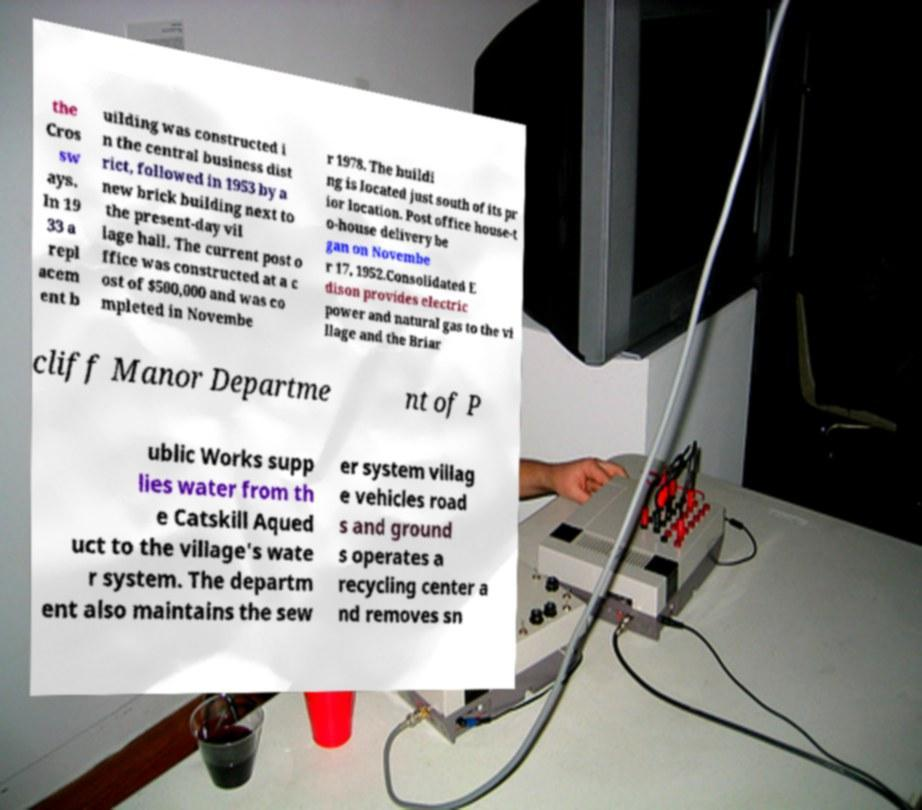For documentation purposes, I need the text within this image transcribed. Could you provide that? the Cros sw ays. In 19 33 a repl acem ent b uilding was constructed i n the central business dist rict, followed in 1953 by a new brick building next to the present-day vil lage hall. The current post o ffice was constructed at a c ost of $500,000 and was co mpleted in Novembe r 1978. The buildi ng is located just south of its pr ior location. Post office house-t o-house delivery be gan on Novembe r 17, 1952.Consolidated E dison provides electric power and natural gas to the vi llage and the Briar cliff Manor Departme nt of P ublic Works supp lies water from th e Catskill Aqued uct to the village's wate r system. The departm ent also maintains the sew er system villag e vehicles road s and ground s operates a recycling center a nd removes sn 